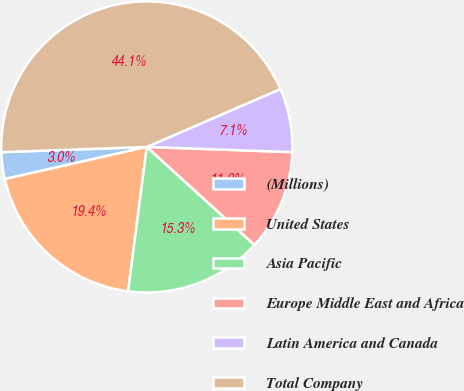Convert chart to OTSL. <chart><loc_0><loc_0><loc_500><loc_500><pie_chart><fcel>(Millions)<fcel>United States<fcel>Asia Pacific<fcel>Europe Middle East and Africa<fcel>Latin America and Canada<fcel>Total Company<nl><fcel>2.97%<fcel>19.41%<fcel>15.3%<fcel>11.19%<fcel>7.08%<fcel>44.07%<nl></chart> 